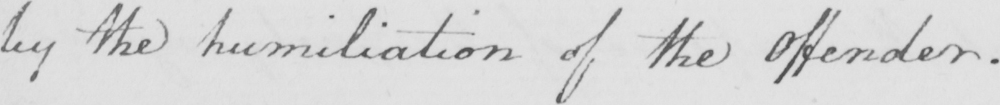Transcribe the text shown in this historical manuscript line. by the humiliation of the Offender . 